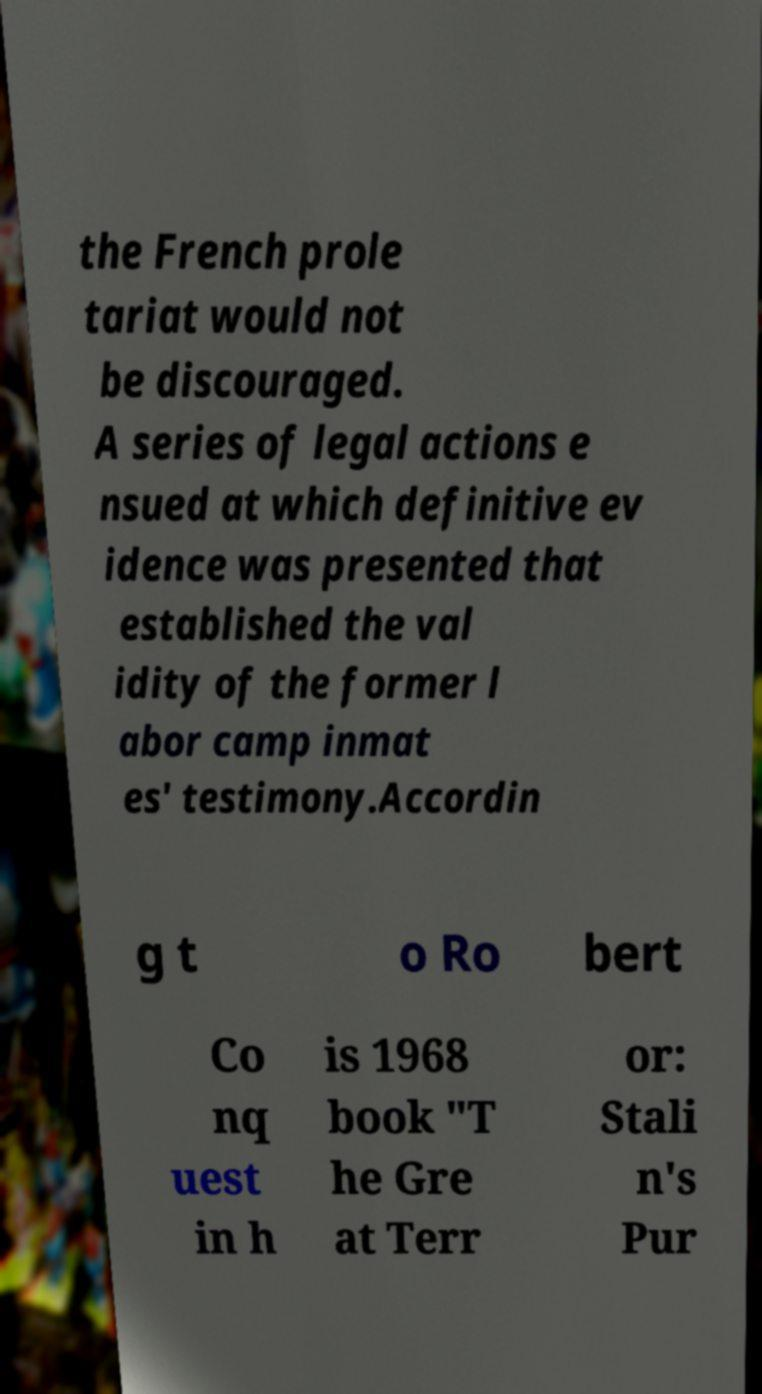There's text embedded in this image that I need extracted. Can you transcribe it verbatim? the French prole tariat would not be discouraged. A series of legal actions e nsued at which definitive ev idence was presented that established the val idity of the former l abor camp inmat es' testimony.Accordin g t o Ro bert Co nq uest in h is 1968 book "T he Gre at Terr or: Stali n's Pur 